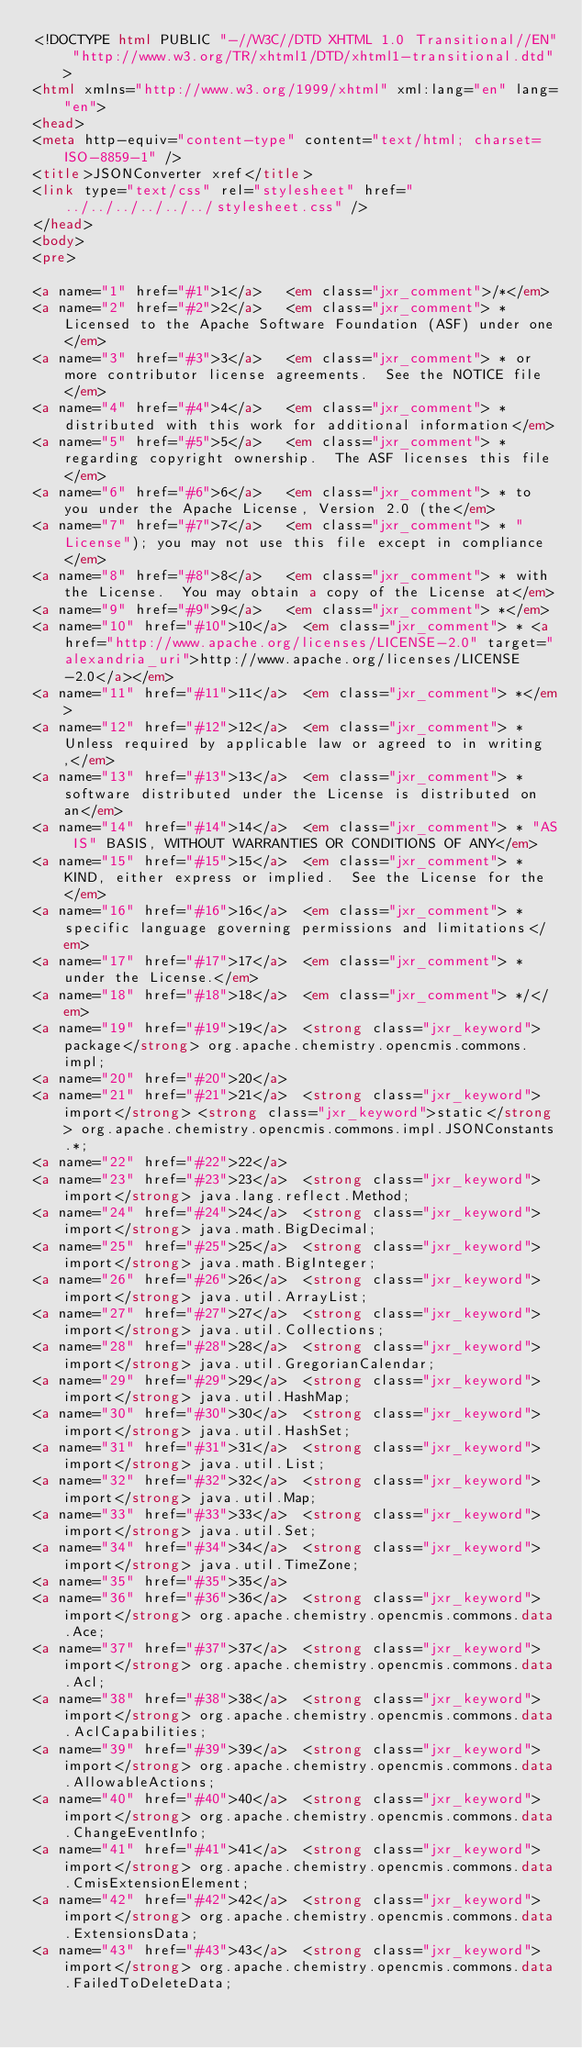<code> <loc_0><loc_0><loc_500><loc_500><_HTML_><!DOCTYPE html PUBLIC "-//W3C//DTD XHTML 1.0 Transitional//EN" "http://www.w3.org/TR/xhtml1/DTD/xhtml1-transitional.dtd">
<html xmlns="http://www.w3.org/1999/xhtml" xml:lang="en" lang="en">
<head>
<meta http-equiv="content-type" content="text/html; charset=ISO-8859-1" />
<title>JSONConverter xref</title>
<link type="text/css" rel="stylesheet" href="../../../../../../stylesheet.css" />
</head>
<body>
<pre>

<a name="1" href="#1">1</a>   <em class="jxr_comment">/*</em>
<a name="2" href="#2">2</a>   <em class="jxr_comment"> * Licensed to the Apache Software Foundation (ASF) under one</em>
<a name="3" href="#3">3</a>   <em class="jxr_comment"> * or more contributor license agreements.  See the NOTICE file</em>
<a name="4" href="#4">4</a>   <em class="jxr_comment"> * distributed with this work for additional information</em>
<a name="5" href="#5">5</a>   <em class="jxr_comment"> * regarding copyright ownership.  The ASF licenses this file</em>
<a name="6" href="#6">6</a>   <em class="jxr_comment"> * to you under the Apache License, Version 2.0 (the</em>
<a name="7" href="#7">7</a>   <em class="jxr_comment"> * "License"); you may not use this file except in compliance</em>
<a name="8" href="#8">8</a>   <em class="jxr_comment"> * with the License.  You may obtain a copy of the License at</em>
<a name="9" href="#9">9</a>   <em class="jxr_comment"> *</em>
<a name="10" href="#10">10</a>  <em class="jxr_comment"> * <a href="http://www.apache.org/licenses/LICENSE-2.0" target="alexandria_uri">http://www.apache.org/licenses/LICENSE-2.0</a></em>
<a name="11" href="#11">11</a>  <em class="jxr_comment"> *</em>
<a name="12" href="#12">12</a>  <em class="jxr_comment"> * Unless required by applicable law or agreed to in writing,</em>
<a name="13" href="#13">13</a>  <em class="jxr_comment"> * software distributed under the License is distributed on an</em>
<a name="14" href="#14">14</a>  <em class="jxr_comment"> * "AS IS" BASIS, WITHOUT WARRANTIES OR CONDITIONS OF ANY</em>
<a name="15" href="#15">15</a>  <em class="jxr_comment"> * KIND, either express or implied.  See the License for the</em>
<a name="16" href="#16">16</a>  <em class="jxr_comment"> * specific language governing permissions and limitations</em>
<a name="17" href="#17">17</a>  <em class="jxr_comment"> * under the License.</em>
<a name="18" href="#18">18</a>  <em class="jxr_comment"> */</em>
<a name="19" href="#19">19</a>  <strong class="jxr_keyword">package</strong> org.apache.chemistry.opencmis.commons.impl;
<a name="20" href="#20">20</a>  
<a name="21" href="#21">21</a>  <strong class="jxr_keyword">import</strong> <strong class="jxr_keyword">static</strong> org.apache.chemistry.opencmis.commons.impl.JSONConstants.*;
<a name="22" href="#22">22</a>  
<a name="23" href="#23">23</a>  <strong class="jxr_keyword">import</strong> java.lang.reflect.Method;
<a name="24" href="#24">24</a>  <strong class="jxr_keyword">import</strong> java.math.BigDecimal;
<a name="25" href="#25">25</a>  <strong class="jxr_keyword">import</strong> java.math.BigInteger;
<a name="26" href="#26">26</a>  <strong class="jxr_keyword">import</strong> java.util.ArrayList;
<a name="27" href="#27">27</a>  <strong class="jxr_keyword">import</strong> java.util.Collections;
<a name="28" href="#28">28</a>  <strong class="jxr_keyword">import</strong> java.util.GregorianCalendar;
<a name="29" href="#29">29</a>  <strong class="jxr_keyword">import</strong> java.util.HashMap;
<a name="30" href="#30">30</a>  <strong class="jxr_keyword">import</strong> java.util.HashSet;
<a name="31" href="#31">31</a>  <strong class="jxr_keyword">import</strong> java.util.List;
<a name="32" href="#32">32</a>  <strong class="jxr_keyword">import</strong> java.util.Map;
<a name="33" href="#33">33</a>  <strong class="jxr_keyword">import</strong> java.util.Set;
<a name="34" href="#34">34</a>  <strong class="jxr_keyword">import</strong> java.util.TimeZone;
<a name="35" href="#35">35</a>  
<a name="36" href="#36">36</a>  <strong class="jxr_keyword">import</strong> org.apache.chemistry.opencmis.commons.data.Ace;
<a name="37" href="#37">37</a>  <strong class="jxr_keyword">import</strong> org.apache.chemistry.opencmis.commons.data.Acl;
<a name="38" href="#38">38</a>  <strong class="jxr_keyword">import</strong> org.apache.chemistry.opencmis.commons.data.AclCapabilities;
<a name="39" href="#39">39</a>  <strong class="jxr_keyword">import</strong> org.apache.chemistry.opencmis.commons.data.AllowableActions;
<a name="40" href="#40">40</a>  <strong class="jxr_keyword">import</strong> org.apache.chemistry.opencmis.commons.data.ChangeEventInfo;
<a name="41" href="#41">41</a>  <strong class="jxr_keyword">import</strong> org.apache.chemistry.opencmis.commons.data.CmisExtensionElement;
<a name="42" href="#42">42</a>  <strong class="jxr_keyword">import</strong> org.apache.chemistry.opencmis.commons.data.ExtensionsData;
<a name="43" href="#43">43</a>  <strong class="jxr_keyword">import</strong> org.apache.chemistry.opencmis.commons.data.FailedToDeleteData;</code> 